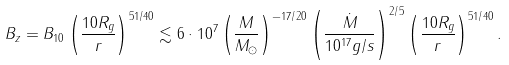<formula> <loc_0><loc_0><loc_500><loc_500>B _ { z } = B _ { 1 0 } \left ( \frac { 1 0 R _ { g } } { r } \right ) ^ { 5 1 / 4 0 } \lesssim 6 \cdot 1 0 ^ { 7 } \left ( \frac { M } { M _ { \odot } } \right ) ^ { - 1 7 / 2 0 } \left ( \frac { \dot { M } } { 1 0 ^ { 1 7 } g / s } \right ) ^ { 2 / 5 } \left ( \frac { 1 0 R _ { g } } { r } \right ) ^ { 5 1 / 4 0 } .</formula> 